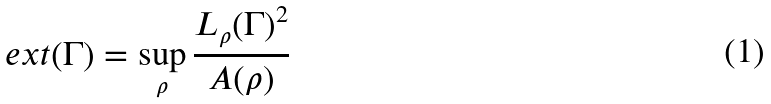<formula> <loc_0><loc_0><loc_500><loc_500>\ e x t ( \Gamma ) = \sup _ { \rho } \frac { L _ { \rho } ( \Gamma ) ^ { 2 } } { A ( \rho ) }</formula> 